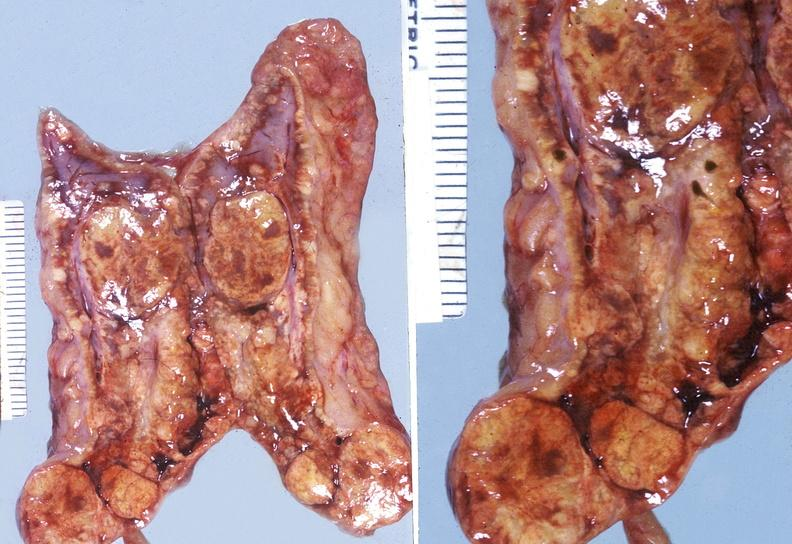what does this image show?
Answer the question using a single word or phrase. Adrenal 